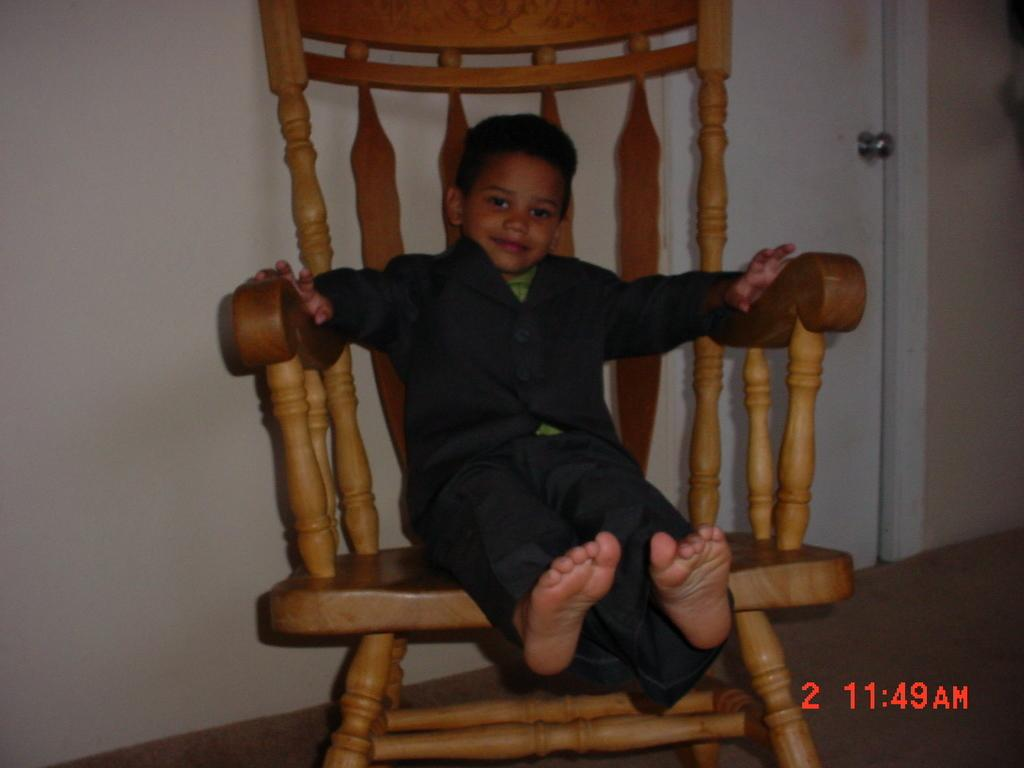What object is located in the middle of the image? There is a chair in the middle of the image. Who is sitting on the chair? A boy is sitting on the chair. What type of clothing is the boy wearing on his lower body? The boy is wearing trousers. What type of clothing is the boy wearing on his upper body? The boy is wearing a t-shirt. What can be seen in the background of the image? There is a wall and a door in the background of the image. What type of bread is the boy eating during the earthquake in the image? There is no bread or earthquake present in the image; it features a boy sitting on a chair wearing trousers and a t-shirt, with a wall and a door in the background. 